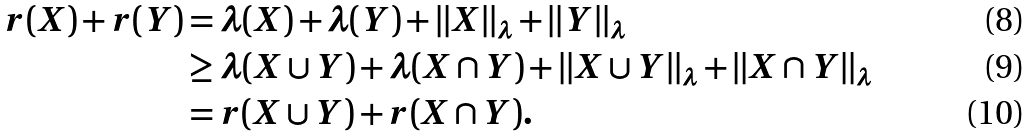Convert formula to latex. <formula><loc_0><loc_0><loc_500><loc_500>r ( X ) + r ( Y ) & = \lambda ( X ) + \lambda ( Y ) + | | X | | _ { \lambda } + | | Y | | _ { \lambda } \\ & \geq \lambda ( X \cup Y ) + \lambda ( X \cap Y ) + | | X \cup Y | | _ { \lambda } + | | X \cap Y | | _ { \lambda } \\ & = r ( X \cup Y ) + r ( X \cap Y ) .</formula> 